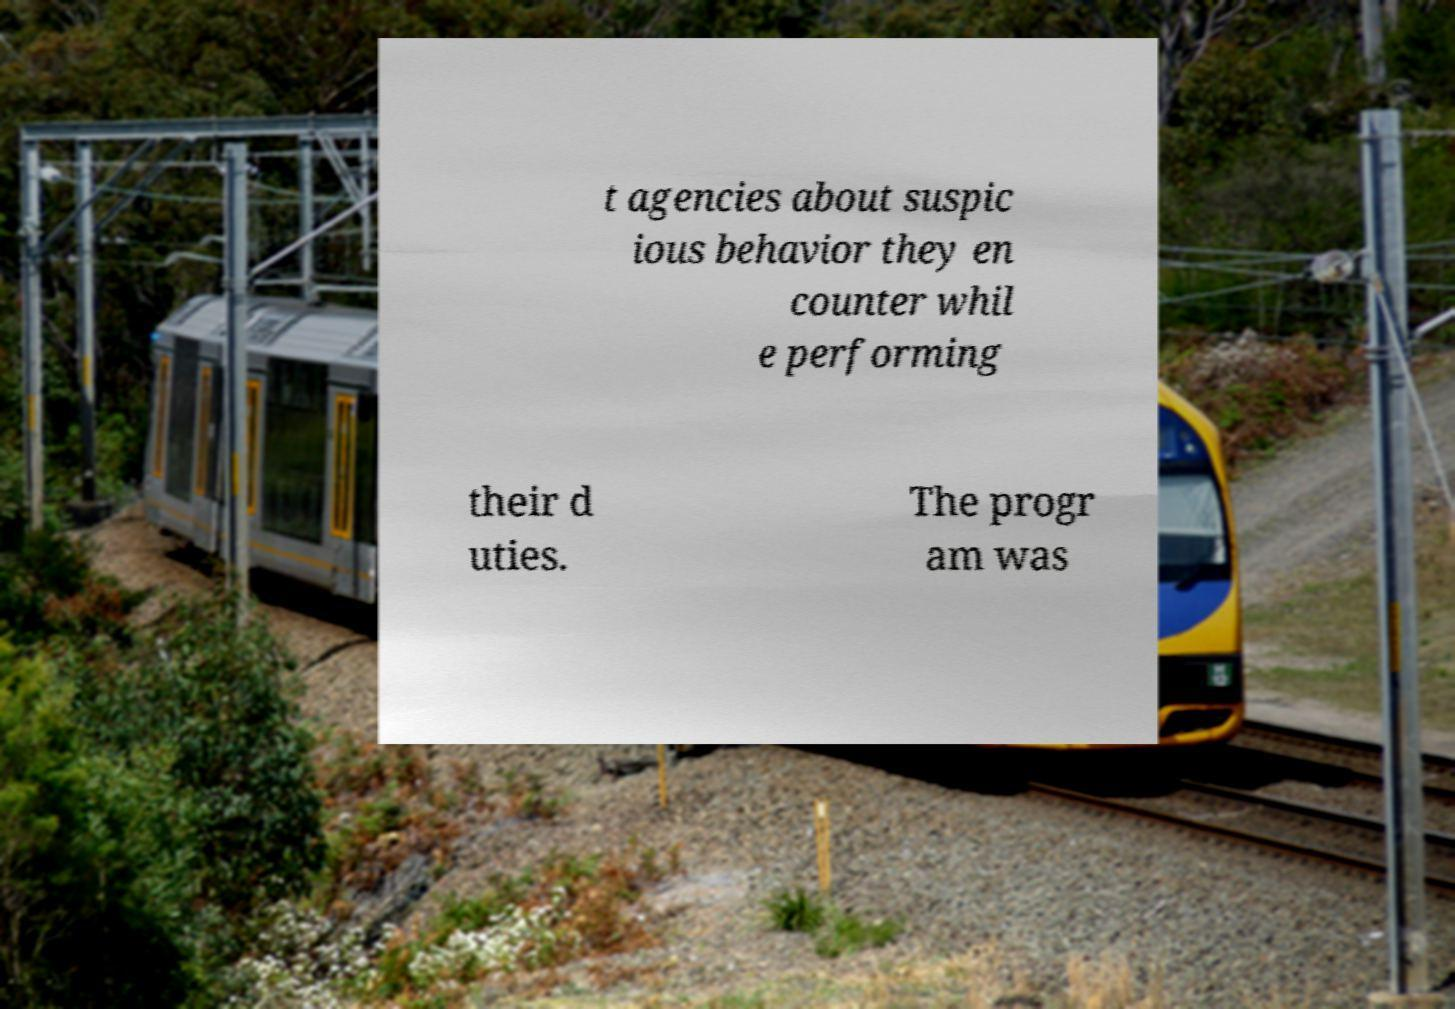What messages or text are displayed in this image? I need them in a readable, typed format. t agencies about suspic ious behavior they en counter whil e performing their d uties. The progr am was 